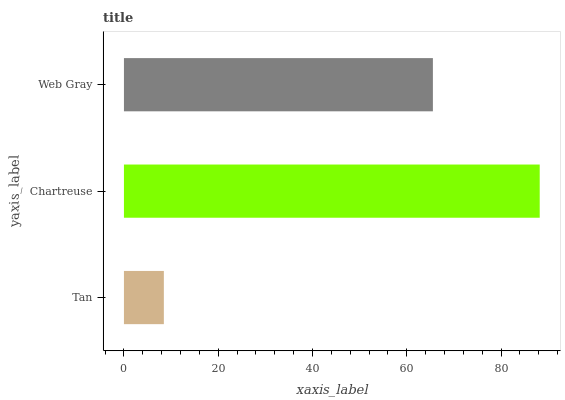Is Tan the minimum?
Answer yes or no. Yes. Is Chartreuse the maximum?
Answer yes or no. Yes. Is Web Gray the minimum?
Answer yes or no. No. Is Web Gray the maximum?
Answer yes or no. No. Is Chartreuse greater than Web Gray?
Answer yes or no. Yes. Is Web Gray less than Chartreuse?
Answer yes or no. Yes. Is Web Gray greater than Chartreuse?
Answer yes or no. No. Is Chartreuse less than Web Gray?
Answer yes or no. No. Is Web Gray the high median?
Answer yes or no. Yes. Is Web Gray the low median?
Answer yes or no. Yes. Is Tan the high median?
Answer yes or no. No. Is Tan the low median?
Answer yes or no. No. 